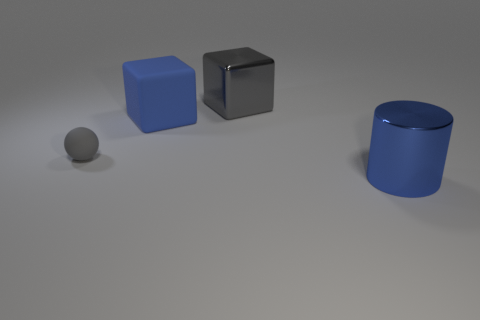Add 4 tiny rubber objects. How many objects exist? 8 Subtract all spheres. How many objects are left? 3 Add 3 big gray cubes. How many big gray cubes are left? 4 Add 2 large green shiny cubes. How many large green shiny cubes exist? 2 Subtract 0 brown cubes. How many objects are left? 4 Subtract all gray cylinders. Subtract all cyan cubes. How many cylinders are left? 1 Subtract all yellow metallic cylinders. Subtract all blue objects. How many objects are left? 2 